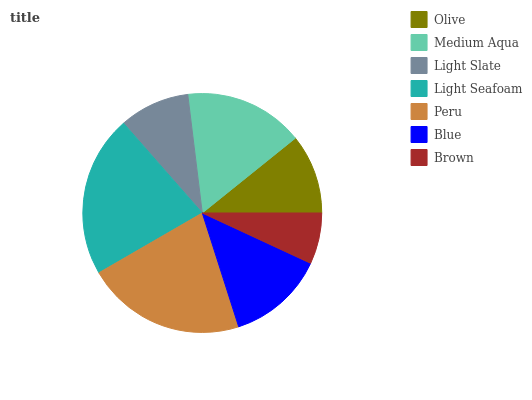Is Brown the minimum?
Answer yes or no. Yes. Is Light Seafoam the maximum?
Answer yes or no. Yes. Is Medium Aqua the minimum?
Answer yes or no. No. Is Medium Aqua the maximum?
Answer yes or no. No. Is Medium Aqua greater than Olive?
Answer yes or no. Yes. Is Olive less than Medium Aqua?
Answer yes or no. Yes. Is Olive greater than Medium Aqua?
Answer yes or no. No. Is Medium Aqua less than Olive?
Answer yes or no. No. Is Blue the high median?
Answer yes or no. Yes. Is Blue the low median?
Answer yes or no. Yes. Is Brown the high median?
Answer yes or no. No. Is Brown the low median?
Answer yes or no. No. 